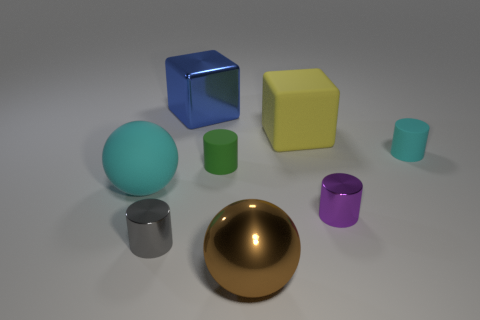Subtract all cubes. How many objects are left? 6 Subtract 2 cubes. How many cubes are left? 0 Subtract all brown balls. Subtract all blue cylinders. How many balls are left? 1 Subtract all gray balls. How many yellow cubes are left? 1 Subtract all big red matte cylinders. Subtract all small green matte objects. How many objects are left? 7 Add 1 cyan rubber things. How many cyan rubber things are left? 3 Add 1 purple objects. How many purple objects exist? 2 Add 1 shiny cylinders. How many objects exist? 9 Subtract all brown spheres. How many spheres are left? 1 Subtract all small green rubber cylinders. How many cylinders are left? 3 